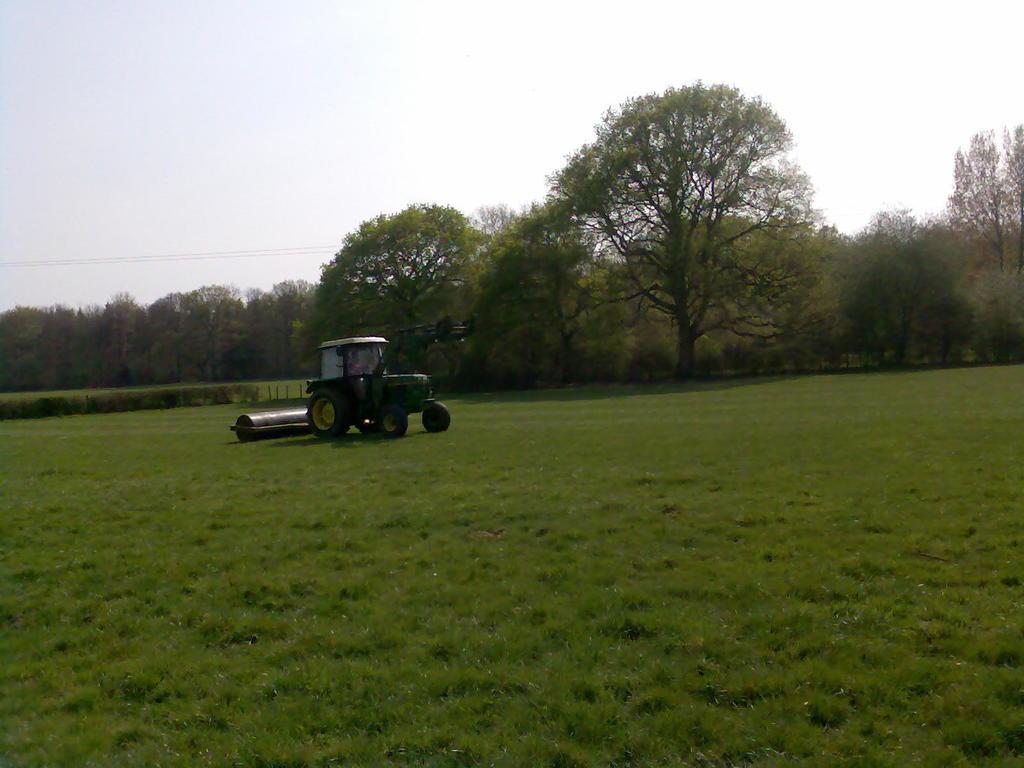What is the main setting of the image? There is an open grass ground in the image. What can be seen on the grass ground? There is a green color tractor on the grass ground. What is visible in the background of the image? There are trees, wires, and the sky visible in the background. What type of wax is being used to polish the crate in the image? There is no crate or wax present in the image. What kind of pets can be seen playing on the grass ground in the image? There are no pets visible in the image; it features an open grass ground with a green color tractor. 